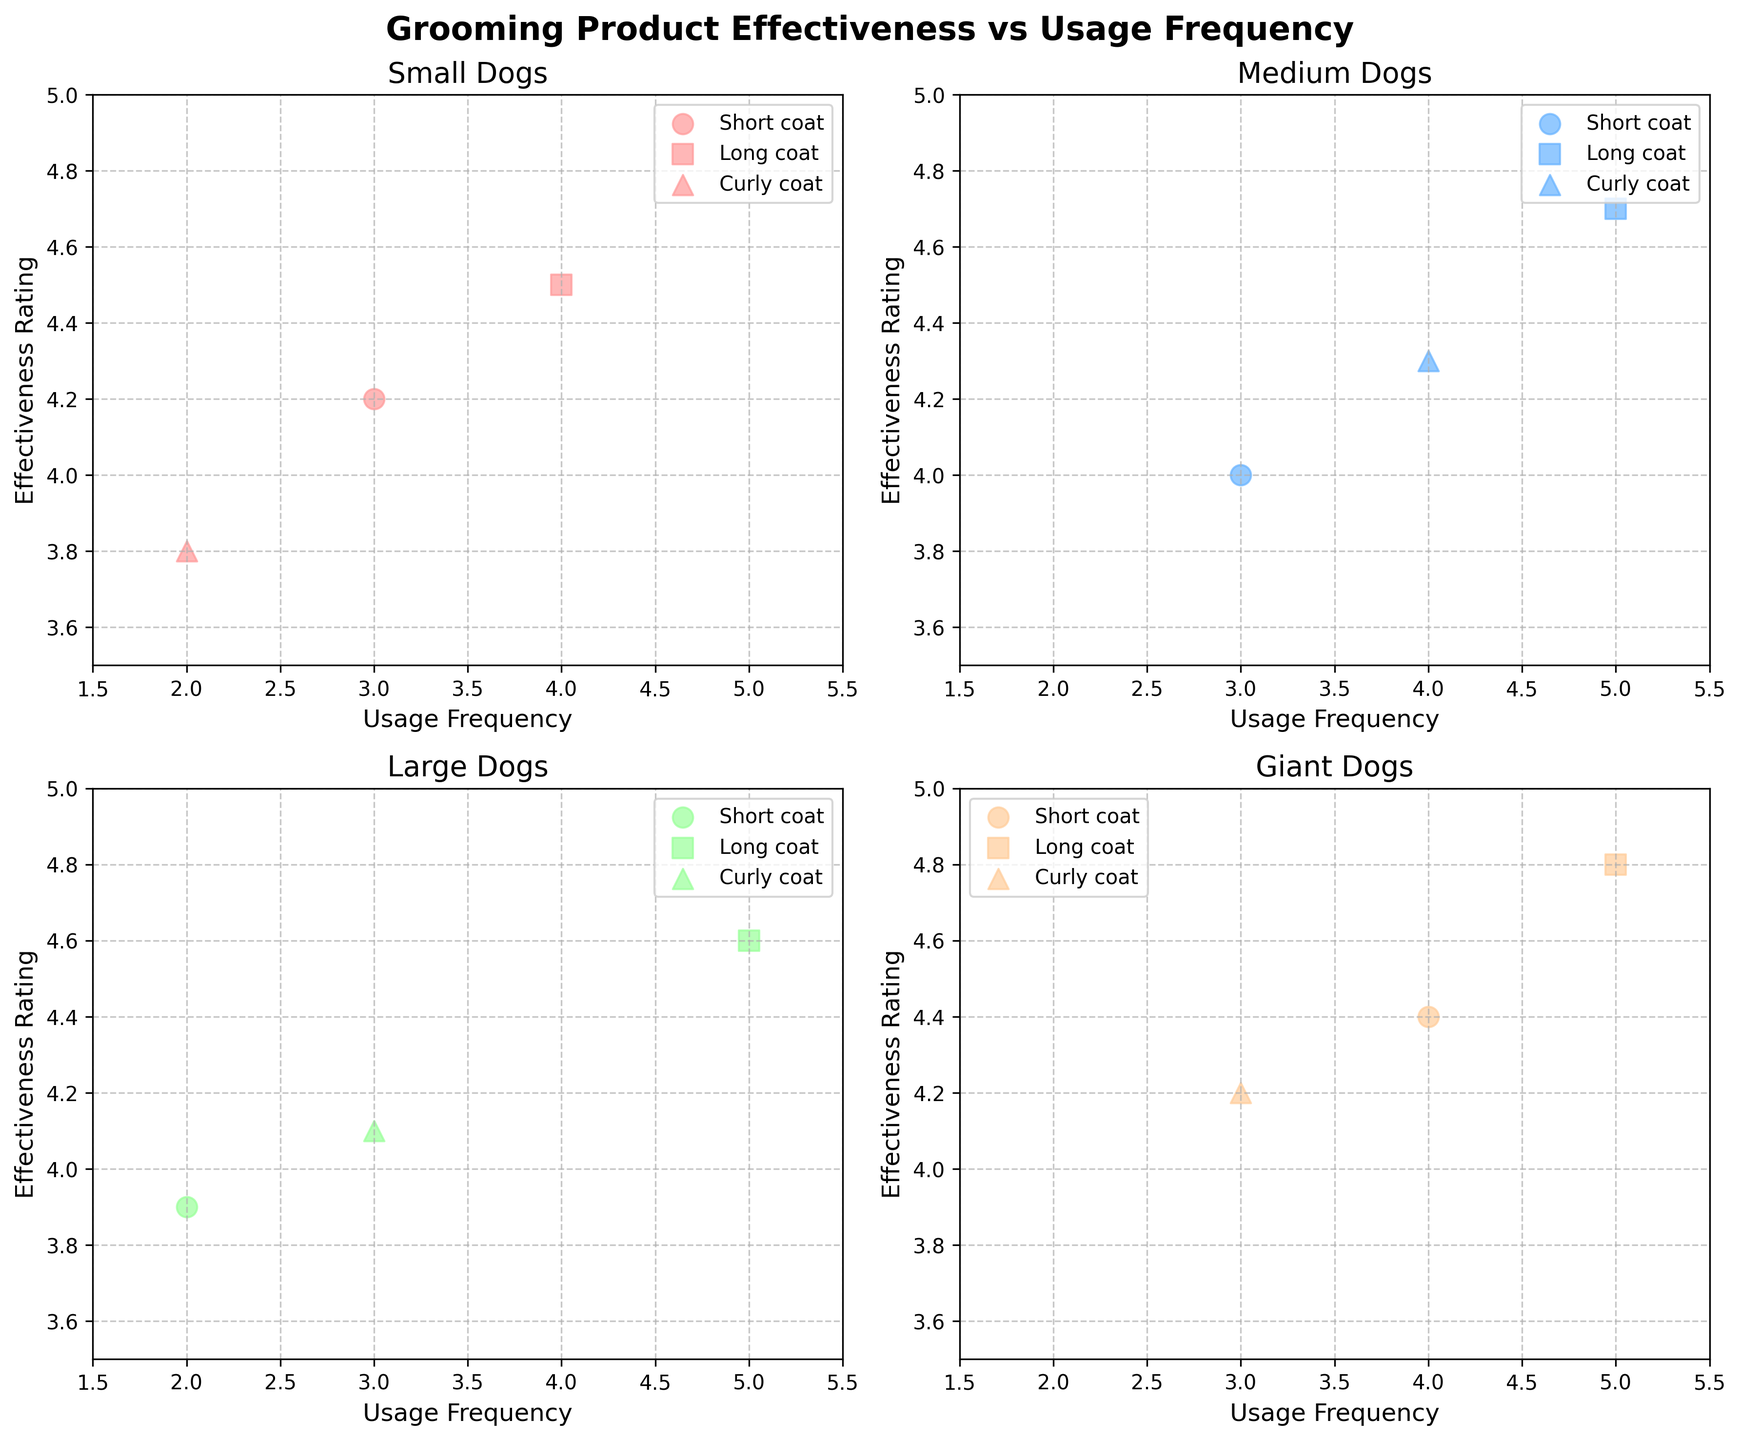What is the title of the figure? The title of the figure is usually located at the top of the plot and summarises the main idea or purpose of the figure. In this case, the title is displaying above the subplots and reads "Grooming Product Effectiveness vs Usage Frequency".
Answer: Grooming Product Effectiveness vs Usage Frequency How many dog sizes are represented in the figure? The figure has four subplots, each dedicated to a specific dog size. The titles of the subplots indicate the different dog sizes.
Answer: Four Which dog size has the highest effectiveness rating for a long coat texture? In the subplot for each dog size, the effectiveness rating for different coat textures is plotted. By comparing the highest y-axis value for long coat textures across all subplots, we see that the Giant dog size has the highest effectiveness rating at 4.8.
Answer: Giant Which product for curly-coated medium dogs has the highest effectiveness rating? The subplot for medium dogs highlights points for curly, short, and long coat textures. By identifying the point for the curly coat and looking at its y-axis value for effectiveness rating, the product with the highest rating is 'Cowboy Magic Detangler & Shine' with a rating of 4.3.
Answer: Cowboy Magic Detangler & Shine Which coat texture shows the least variance in effectiveness ratings across all dog sizes? To determine this, compare the spread of effectiveness ratings (y-axis values) for each coat texture type across all subplots. The short coat texture shows the least variance in effectiveness ratings ranging roughly between 3.9 and 4.4.
Answer: Short What's the average usage frequency of grooming products for large dogs? Calculate the average of the usage frequency values (x-axis) for large dogs across short, long, and curly coat textures. The values are 2, 5, and 3. Summing these values gives 10, and dividing by the number of points (3) gives an average usage frequency of 3.33.
Answer: 3.33 Which dog size and coat texture combination has the highest usage frequency? Look at the x-axis values across all subplots to identify the highest value. The highest usage frequency is 5, and a check on the respective subplot shows that Giant dogs with a long coat texture have this frequency.
Answer: Giant, Long Is the effectiveness rating for large dogs with a long coat higher than that for small dogs with a long coat? In the subplot for large dogs, the long coat texture has an effectiveness rating of 4.6. In the subplot for small dogs, the long coat texture rating is 4.5. Comparing these two values, the large dog has a higher rating.
Answer: Yes For medium dogs, which coat texture has the lowest effectiveness rating? In the subplot for medium dogs, compare the y-axis values for short, long, and curly coat textures. The short coat texture has the lowest effectiveness rating at 4.0.
Answer: Short Which grooming product has a higher effectiveness rating for curly-coated dogs: Earthbath Oatmeal & Aloe Pet Shampoo (small size) or Miracle Coat Detangling Dog Spray (giant size)? For curly-coated dogs, check the effectiveness rating in the subplots for small and giant dog sizes. Earthbath Oatmeal & Aloe Pet Shampoo has a rating of 3.8, and Miracle Coat Detangling Dog Spray has a rating of 4.2. Thus, Miracle Coat Detangling Dog Spray has the higher rating.
Answer: Miracle Coat Detangling Dog Spray 